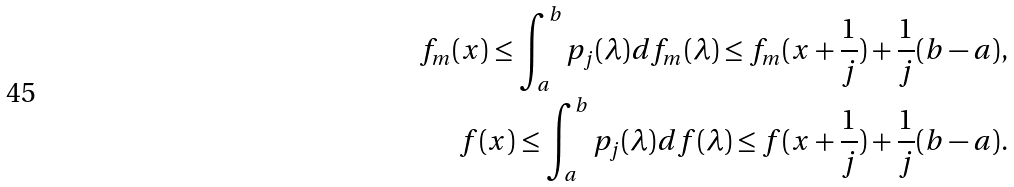<formula> <loc_0><loc_0><loc_500><loc_500>f _ { m } ( x ) \leq \int _ { a } ^ { b } p _ { j } ( \lambda ) d f _ { m } ( \lambda ) \leq f _ { m } ( x + \frac { 1 } { j } ) + \frac { 1 } { j } ( b - a ) , \\ f ( x ) \leq \int _ { a } ^ { b } p _ { j } ( \lambda ) d f ( \lambda ) \leq f ( x + \frac { 1 } { j } ) + \frac { 1 } { j } ( b - a ) .</formula> 